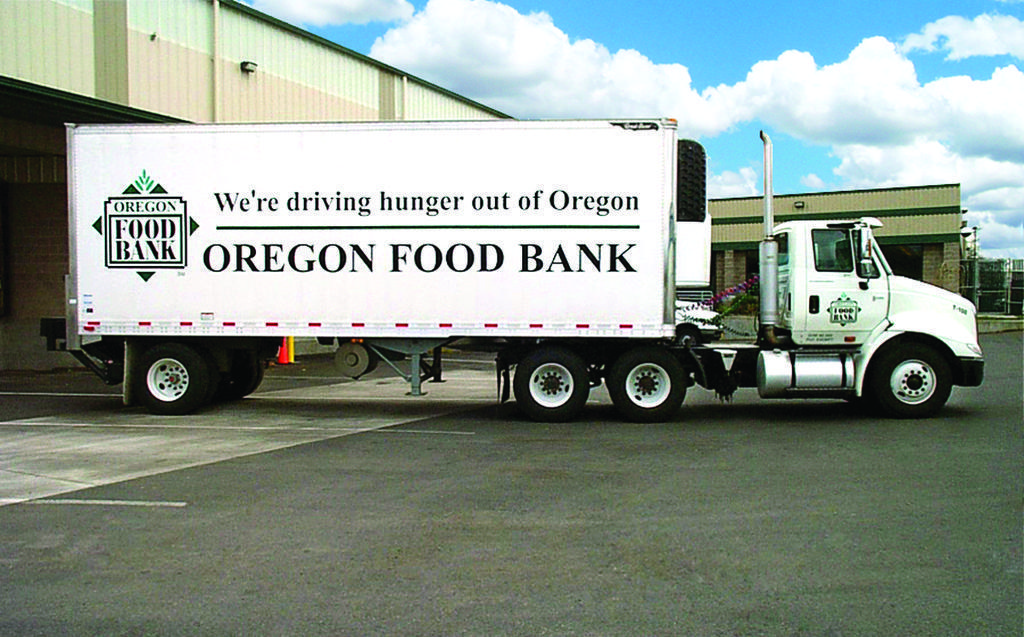Describe this image in one or two sentences. In this image we can see a truck on the road, sheds, trees and sky with clouds in the background. 